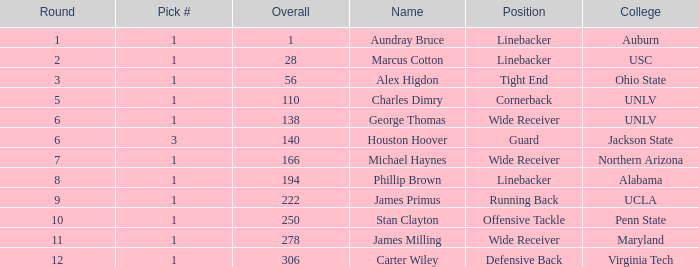At what pick position was aundray bruce chosen? 1.0. 